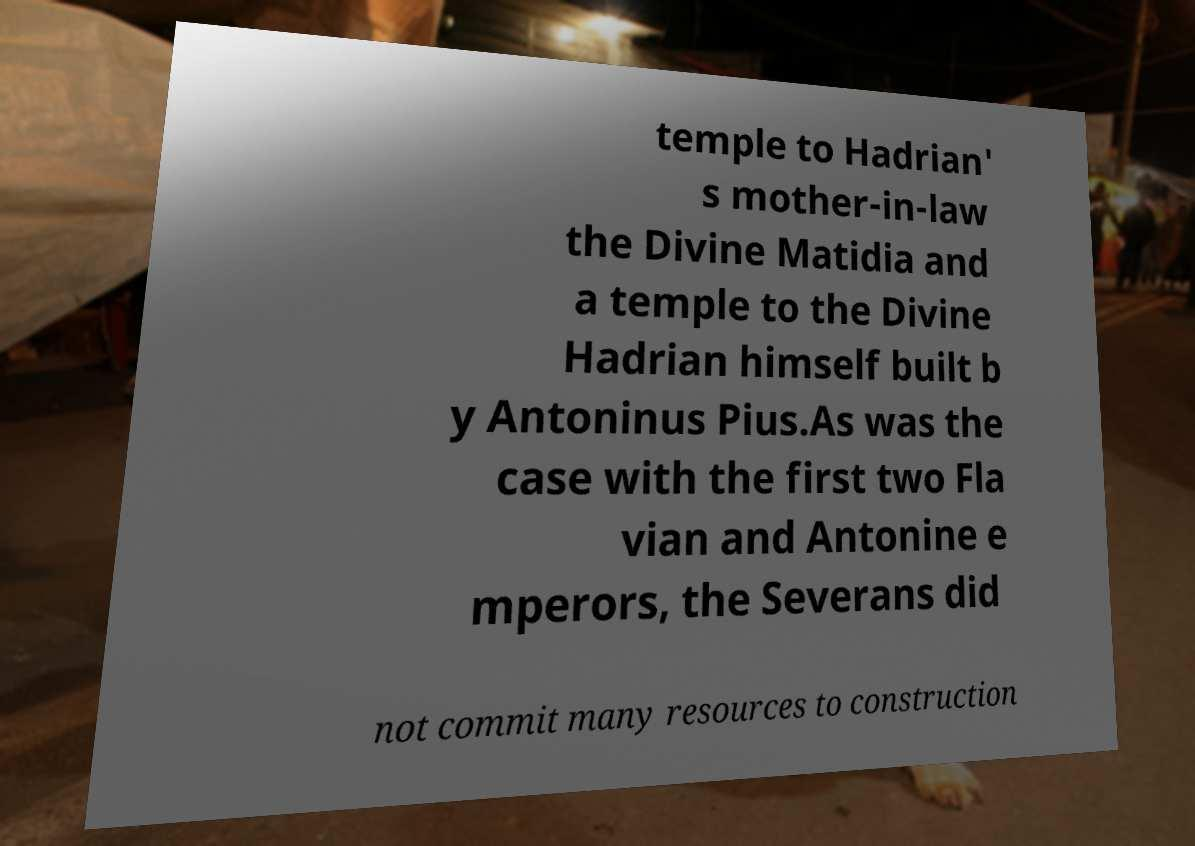Can you read and provide the text displayed in the image?This photo seems to have some interesting text. Can you extract and type it out for me? temple to Hadrian' s mother-in-law the Divine Matidia and a temple to the Divine Hadrian himself built b y Antoninus Pius.As was the case with the first two Fla vian and Antonine e mperors, the Severans did not commit many resources to construction 